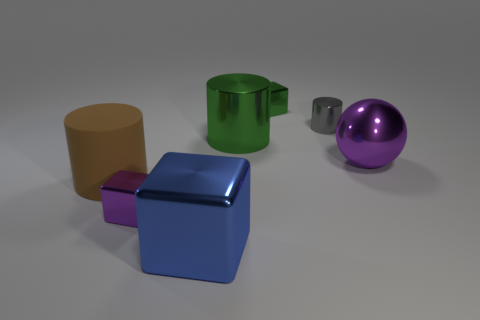There is a block that is to the left of the big thing in front of the large matte cylinder; how many purple metal blocks are in front of it?
Ensure brevity in your answer.  0. Are there any large cubes that have the same color as the tiny cylinder?
Offer a very short reply. No. The matte cylinder that is the same size as the blue metallic object is what color?
Your answer should be compact. Brown. There is a large metallic object that is in front of the small metal object that is in front of the purple metallic thing that is on the right side of the green cylinder; what shape is it?
Provide a short and direct response. Cube. How many tiny purple metallic blocks are in front of the purple metallic thing on the right side of the small gray shiny cylinder?
Your response must be concise. 1. There is a tiny thing to the left of the blue cube; is its shape the same as the large metallic object in front of the large brown matte object?
Provide a succinct answer. Yes. There is a small metallic cylinder; how many large cylinders are to the left of it?
Your answer should be very brief. 2. Is the material of the cube that is behind the tiny gray shiny object the same as the big purple object?
Your answer should be compact. Yes. There is a big thing that is the same shape as the small green object; what is its color?
Offer a very short reply. Blue. There is a gray metallic object; what shape is it?
Your response must be concise. Cylinder. 